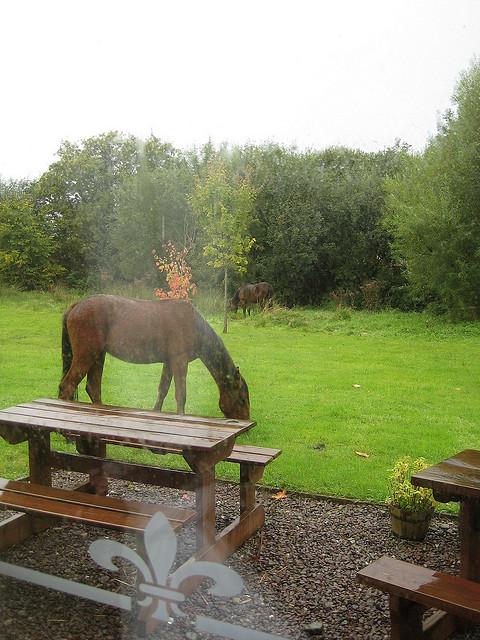Is the horse grazing?
Write a very short answer. Yes. How many animals in this photo?
Answer briefly. 2. What is the motif etched or painted onto the window?
Give a very brief answer. Fleur de lis. 